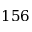<formula> <loc_0><loc_0><loc_500><loc_500>1 5 6</formula> 